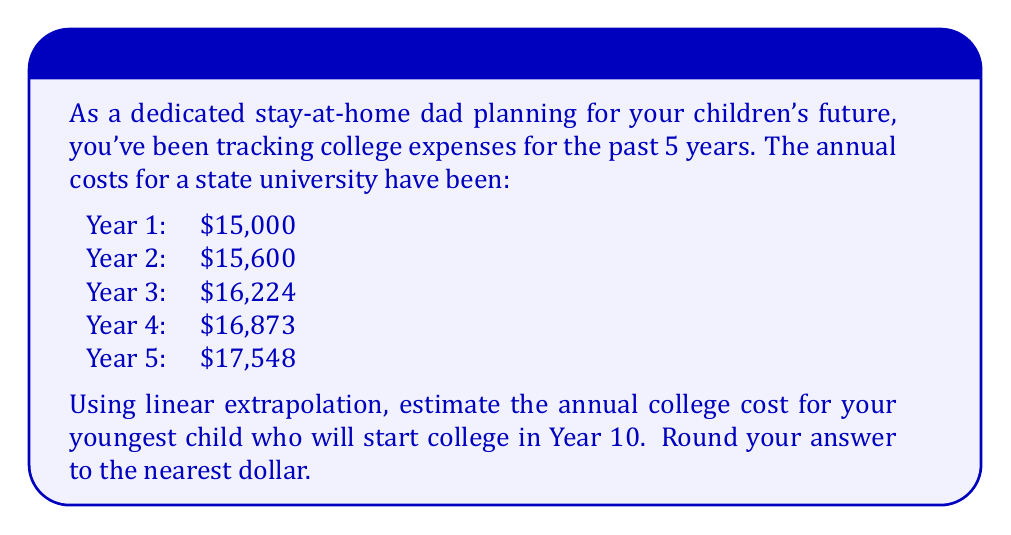Can you answer this question? To solve this problem using linear extrapolation, we'll follow these steps:

1) First, we need to find the average rate of increase per year. We can do this by calculating the total increase over the 5 years and dividing by 4 (the number of intervals):

   Total increase = $17,548 - $15,000 = $2,548
   Average yearly increase = $2,548 / 4 = $637

2) We can verify this by noting that each year's cost is approximately 1.04 times the previous year's cost (4% increase).

3) Now, we can use the linear extrapolation formula:

   $$y = y_0 + m(x - x_0)$$

   Where:
   $y$ is the predicted value
   $y_0$ is the last known value ($17,548)
   $m$ is the rate of change ($637 per year)
   $x$ is the target year (10)
   $x_0$ is the last known year (5)

4) Plugging in our values:

   $$y = 17,548 + 637(10 - 5)$$

5) Simplifying:

   $$y = 17,548 + 637(5) = 17,548 + 3,185 = 20,733$$

6) Rounding to the nearest dollar:

   $20,733
Answer: $20,733 